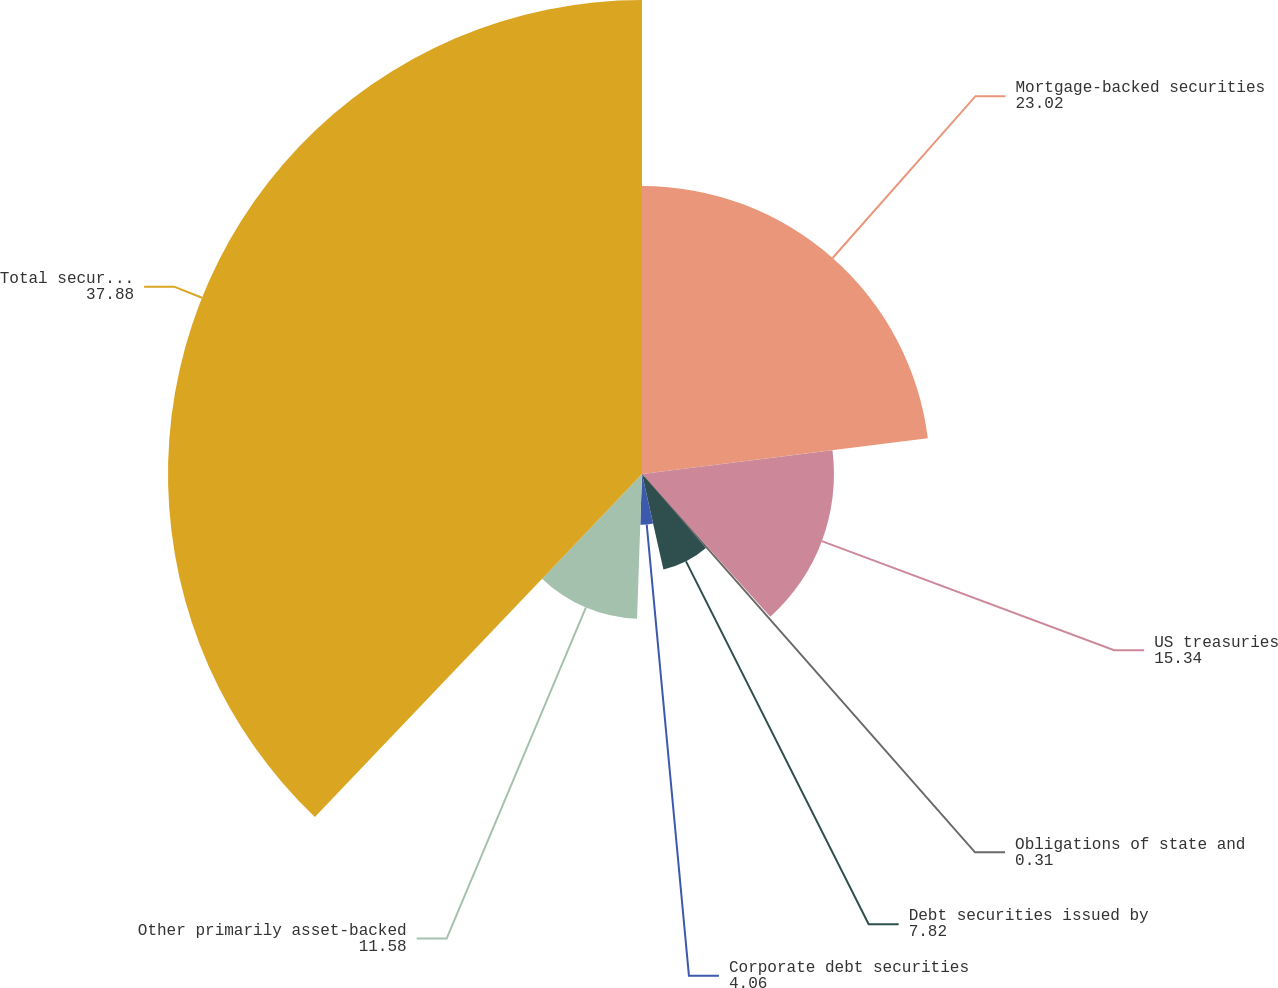Convert chart. <chart><loc_0><loc_0><loc_500><loc_500><pie_chart><fcel>Mortgage-backed securities<fcel>US treasuries<fcel>Obligations of state and<fcel>Debt securities issued by<fcel>Corporate debt securities<fcel>Other primarily asset-backed<fcel>Total securities with<nl><fcel>23.02%<fcel>15.34%<fcel>0.31%<fcel>7.82%<fcel>4.06%<fcel>11.58%<fcel>37.88%<nl></chart> 